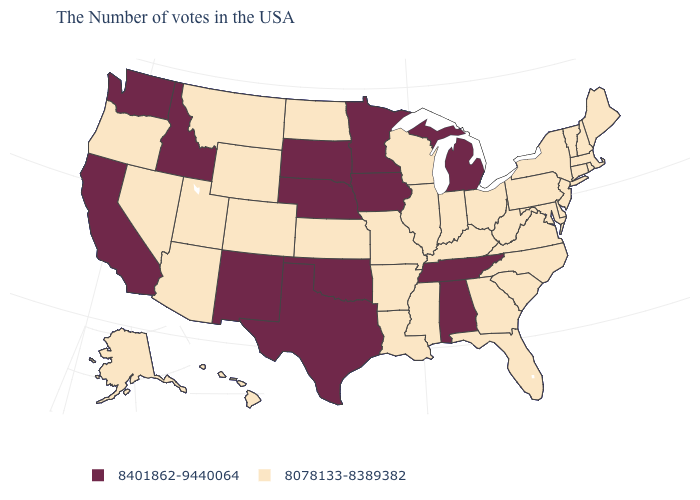What is the value of Arizona?
Keep it brief. 8078133-8389382. Among the states that border Oklahoma , which have the highest value?
Write a very short answer. Texas, New Mexico. How many symbols are there in the legend?
Short answer required. 2. Does Missouri have the highest value in the MidWest?
Write a very short answer. No. Name the states that have a value in the range 8401862-9440064?
Quick response, please. Michigan, Alabama, Tennessee, Minnesota, Iowa, Nebraska, Oklahoma, Texas, South Dakota, New Mexico, Idaho, California, Washington. What is the value of New York?
Write a very short answer. 8078133-8389382. Does Georgia have the lowest value in the South?
Quick response, please. Yes. What is the lowest value in the South?
Give a very brief answer. 8078133-8389382. Name the states that have a value in the range 8078133-8389382?
Short answer required. Maine, Massachusetts, Rhode Island, New Hampshire, Vermont, Connecticut, New York, New Jersey, Delaware, Maryland, Pennsylvania, Virginia, North Carolina, South Carolina, West Virginia, Ohio, Florida, Georgia, Kentucky, Indiana, Wisconsin, Illinois, Mississippi, Louisiana, Missouri, Arkansas, Kansas, North Dakota, Wyoming, Colorado, Utah, Montana, Arizona, Nevada, Oregon, Alaska, Hawaii. Name the states that have a value in the range 8078133-8389382?
Short answer required. Maine, Massachusetts, Rhode Island, New Hampshire, Vermont, Connecticut, New York, New Jersey, Delaware, Maryland, Pennsylvania, Virginia, North Carolina, South Carolina, West Virginia, Ohio, Florida, Georgia, Kentucky, Indiana, Wisconsin, Illinois, Mississippi, Louisiana, Missouri, Arkansas, Kansas, North Dakota, Wyoming, Colorado, Utah, Montana, Arizona, Nevada, Oregon, Alaska, Hawaii. What is the lowest value in states that border California?
Keep it brief. 8078133-8389382. Name the states that have a value in the range 8401862-9440064?
Keep it brief. Michigan, Alabama, Tennessee, Minnesota, Iowa, Nebraska, Oklahoma, Texas, South Dakota, New Mexico, Idaho, California, Washington. Name the states that have a value in the range 8078133-8389382?
Answer briefly. Maine, Massachusetts, Rhode Island, New Hampshire, Vermont, Connecticut, New York, New Jersey, Delaware, Maryland, Pennsylvania, Virginia, North Carolina, South Carolina, West Virginia, Ohio, Florida, Georgia, Kentucky, Indiana, Wisconsin, Illinois, Mississippi, Louisiana, Missouri, Arkansas, Kansas, North Dakota, Wyoming, Colorado, Utah, Montana, Arizona, Nevada, Oregon, Alaska, Hawaii. What is the lowest value in the Northeast?
Be succinct. 8078133-8389382. 